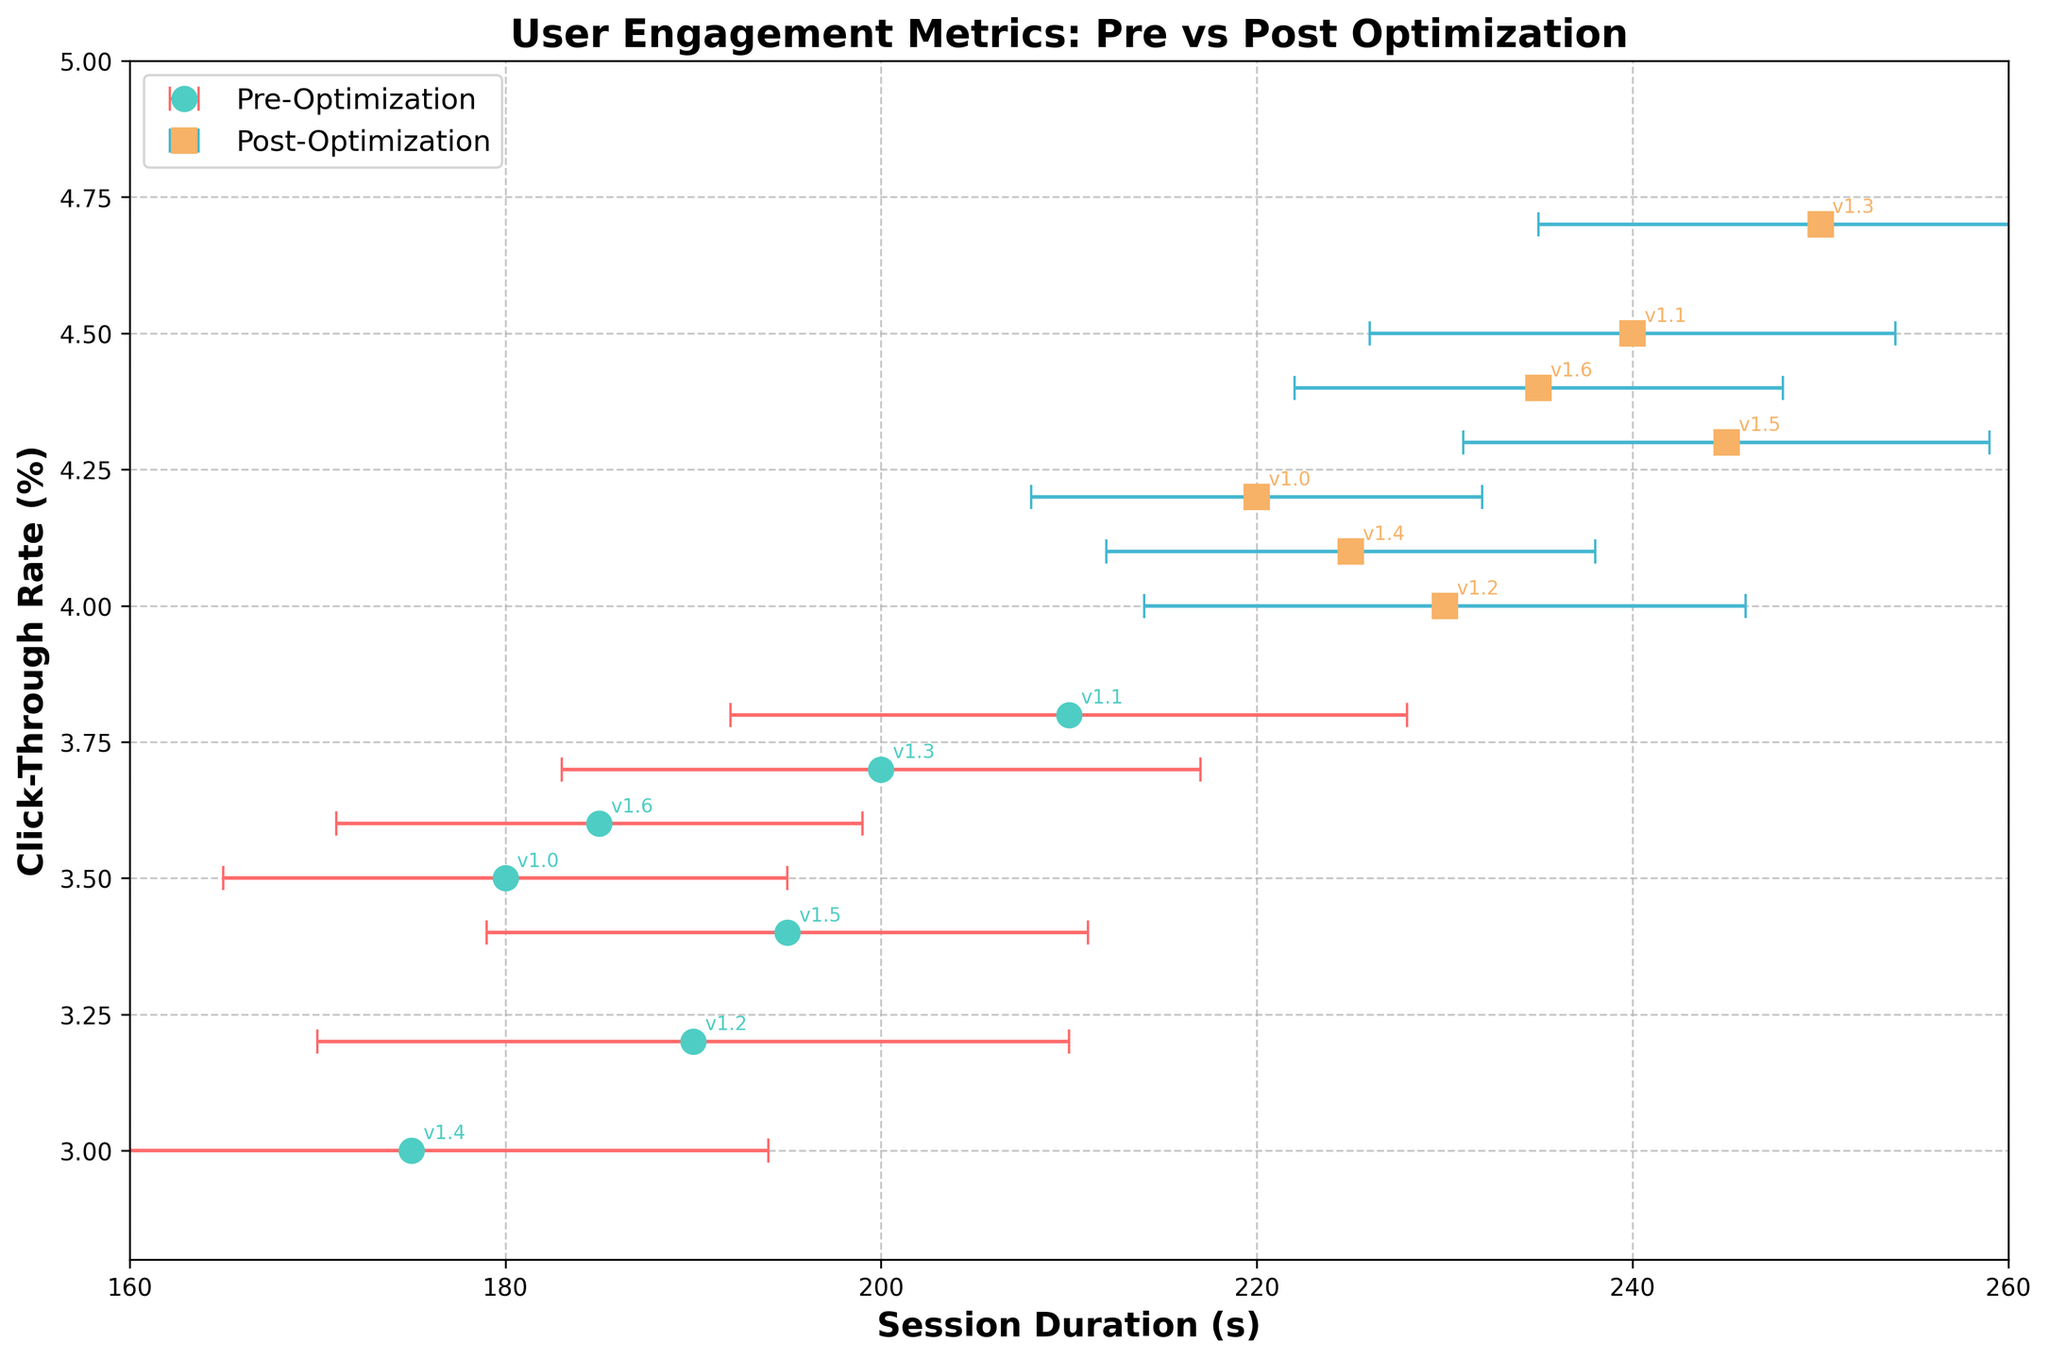What is the title of the plot? The title is at the top of the plot in bold text. It reads "User Engagement Metrics: Pre vs Post Optimization."
Answer: User Engagement Metrics: Pre vs Post Optimization How many versions of the web application are displayed in the plot? There are annotations for each version visible within the plot, and they go from v1.0 to v1.6.
Answer: 7 What are the x-axis and y-axis labels? The x-axis label is "Session Duration (s)," and the y-axis label is "Click-Through Rate (%)." Both are in bold text at the bottom and left sides, respectively.
Answer: Session Duration (s), Click-Through Rate (%) What is the range for the y-axis? The y-axis spans from 2.8% to 5.0%, which can be seen by looking at the minimum and maximum tick values on the left side of the plot.
Answer: 2.8 to 5.0 Which version shows the highest post-optimization click-through rate? To identify this, look at the post-optimization square markers and find the highest position on the y-axis. Version v1.3 has the highest CTR post-optimization at 4.7%.
Answer: v1.3 What is the difference in session duration between versions 1.3 pre- and post-optimization? The session duration for version 1.3 pre-optimization is 200 seconds, and post-optimization is 250 seconds. The difference is 250 - 200 = 50 seconds.
Answer: 50 seconds Which group of data points (pre- or post-optimization) shows higher variability in session duration? The error bars represent variability. By comparing the lengths of the error bars, pre-optimization points generally have longer error bars indicating more variability.
Answer: Pre-optimization Which version experienced the smallest increase in session duration post-optimization? Compare the differences in session duration for each version: v1.0 (220-180=40), v1.1 (240-210=30), v1.2 (230-190=40), v1.3 (250-200=50), v1.4 (225-175=50), v1.5 (245-195=50), v1.6 (235-185=50). Version 1.1 had the smallest increase of 30 seconds.
Answer: v1.1 Which version had a click-through rate below 4.0% post-optimization? By examining the post-optimization square markers along the y-axis, version v1.2 has a CTR below 4.0% post-optimization at 4.0%.
Answer: v1.2 What is the overall trend in click-through rate from pre- to post-optimization? Compare the positions of the pre-optimization circles to the post-optimization squares. The trend shows that all post-optimization CTRs are higher than pre-optimization CTRs, indicating an overall improvement.
Answer: Improvement 